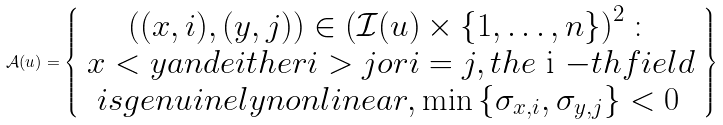<formula> <loc_0><loc_0><loc_500><loc_500>\mathcal { A } ( u ) = \left \{ \begin{array} { c } \left ( ( x , i ) , ( y , j ) \right ) \in \left ( \mathcal { I } ( u ) \times \{ 1 , \dots , n \} \right ) ^ { 2 } \colon \\ x < y a n d e i t h e r i > j o r i = j , t h e $ i $ - t h f i e l d \\ i s g e n u i n e l y n o n l i n e a r , \min \left \{ \sigma _ { x , i } , \sigma _ { y , j } \right \} < 0 \, \end{array} \right \}</formula> 